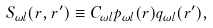Convert formula to latex. <formula><loc_0><loc_0><loc_500><loc_500>S _ { \omega l } ( r , r ^ { \prime } ) \equiv C _ { \omega l } p _ { \omega l } ( r ) q _ { \omega l } ( r ^ { \prime } ) ,</formula> 